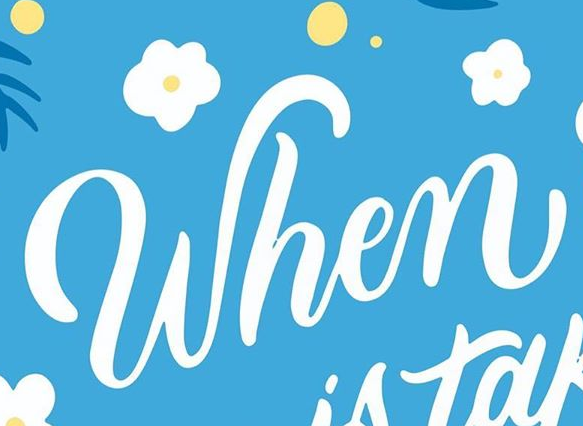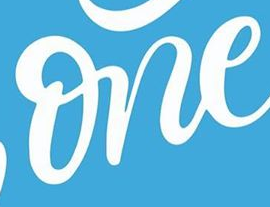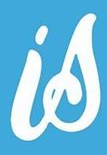Read the text content from these images in order, separated by a semicolon. When; one; is 